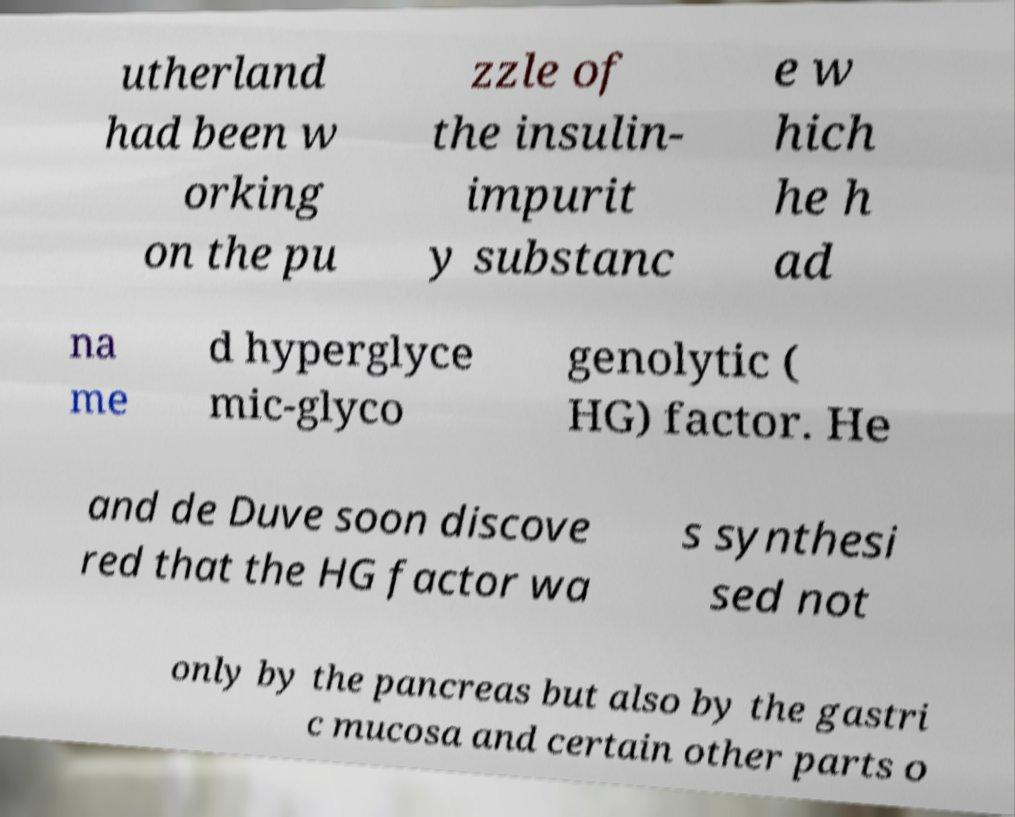For documentation purposes, I need the text within this image transcribed. Could you provide that? utherland had been w orking on the pu zzle of the insulin- impurit y substanc e w hich he h ad na me d hyperglyce mic-glyco genolytic ( HG) factor. He and de Duve soon discove red that the HG factor wa s synthesi sed not only by the pancreas but also by the gastri c mucosa and certain other parts o 